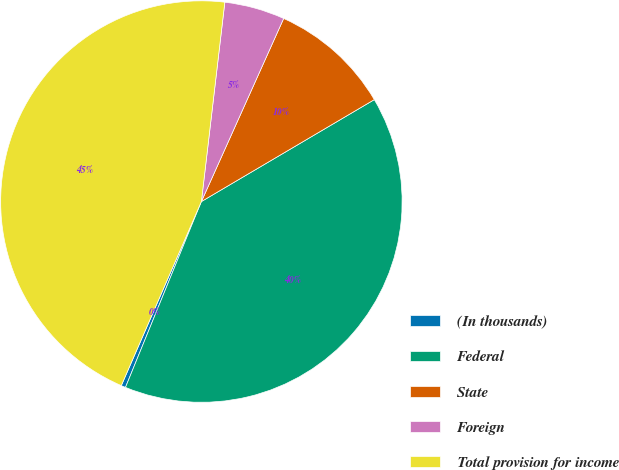Convert chart. <chart><loc_0><loc_0><loc_500><loc_500><pie_chart><fcel>(In thousands)<fcel>Federal<fcel>State<fcel>Foreign<fcel>Total provision for income<nl><fcel>0.36%<fcel>39.65%<fcel>9.8%<fcel>4.86%<fcel>45.33%<nl></chart> 